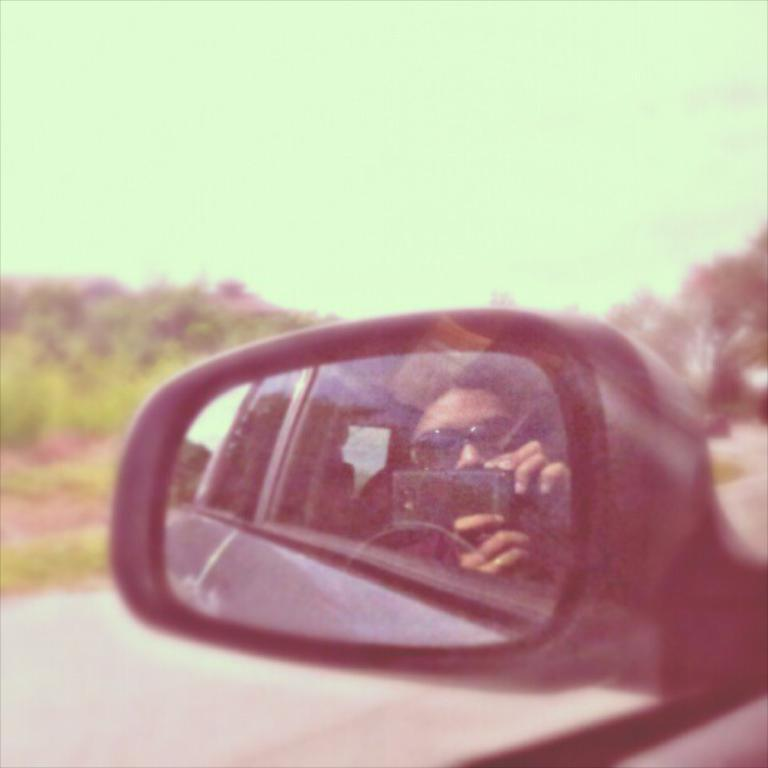What is the main subject of the image? The main subject of the image is the side mirror of a vehicle. Who or what can be seen in the side mirror? A woman is visible in the side mirror. What is the woman holding in the image? The woman is holding a mobile. What accessory is the woman wearing in the image? The woman is wearing sunglasses. What type of natural scenery is visible in the image? Trees are visible in the image. What type of industry can be seen in the background of the image? There is no industry visible in the image; it only shows a side mirror with a woman and trees in the background. What dish is the woman cooking in the image? There is no cooking or dish preparation visible in the image; the woman is holding a mobile and wearing sunglasses. 